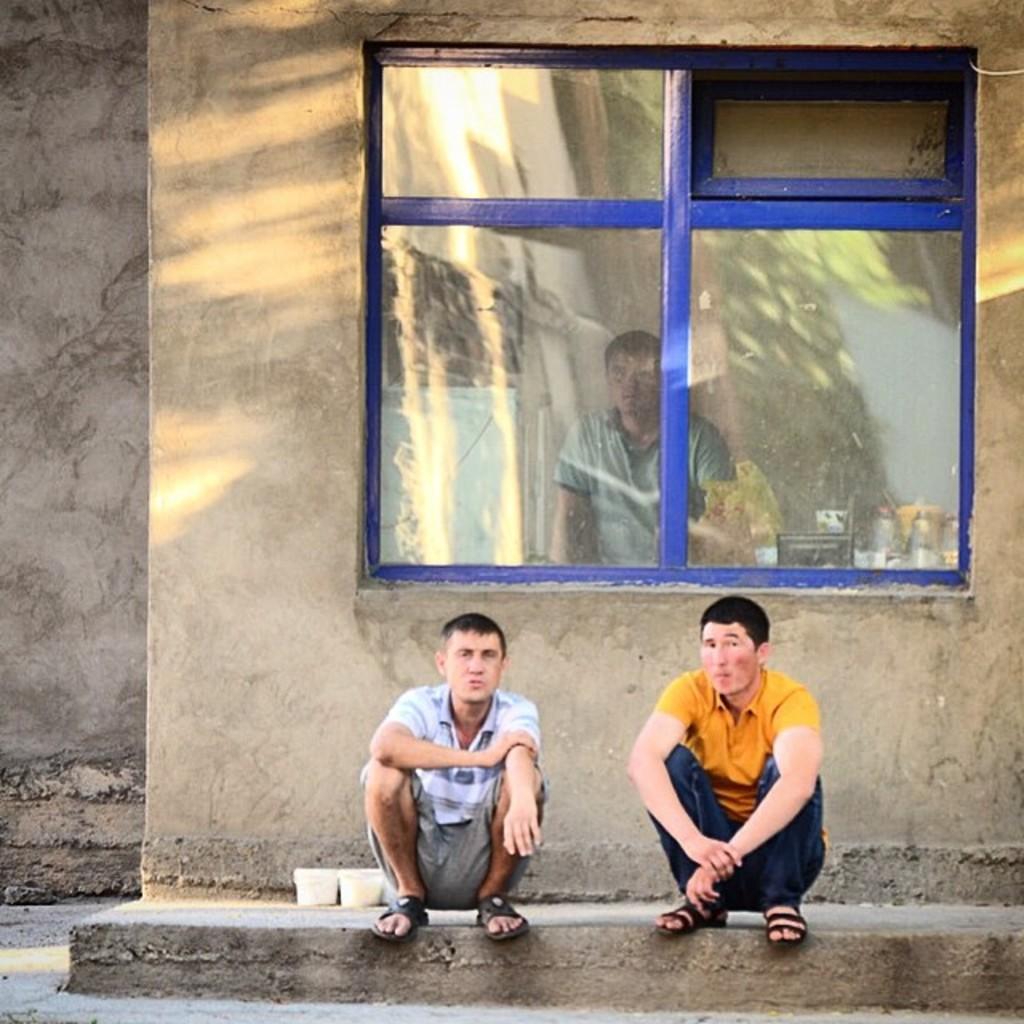Could you give a brief overview of what you see in this image? In this image I can see two men are sitting on the floor. In the middle it is a glass window. 